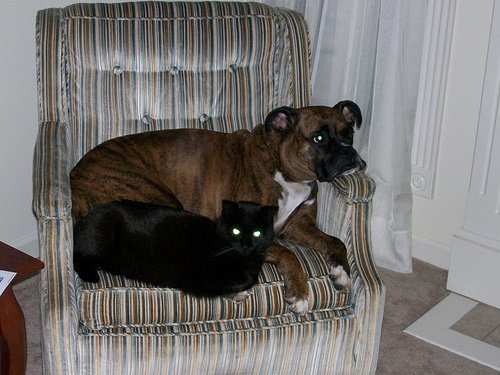Describe the objects in this image and their specific colors. I can see chair in darkgray, gray, and black tones, couch in darkgray, gray, and black tones, dog in darkgray, black, and maroon tones, and cat in darkgray, black, gray, and ivory tones in this image. 